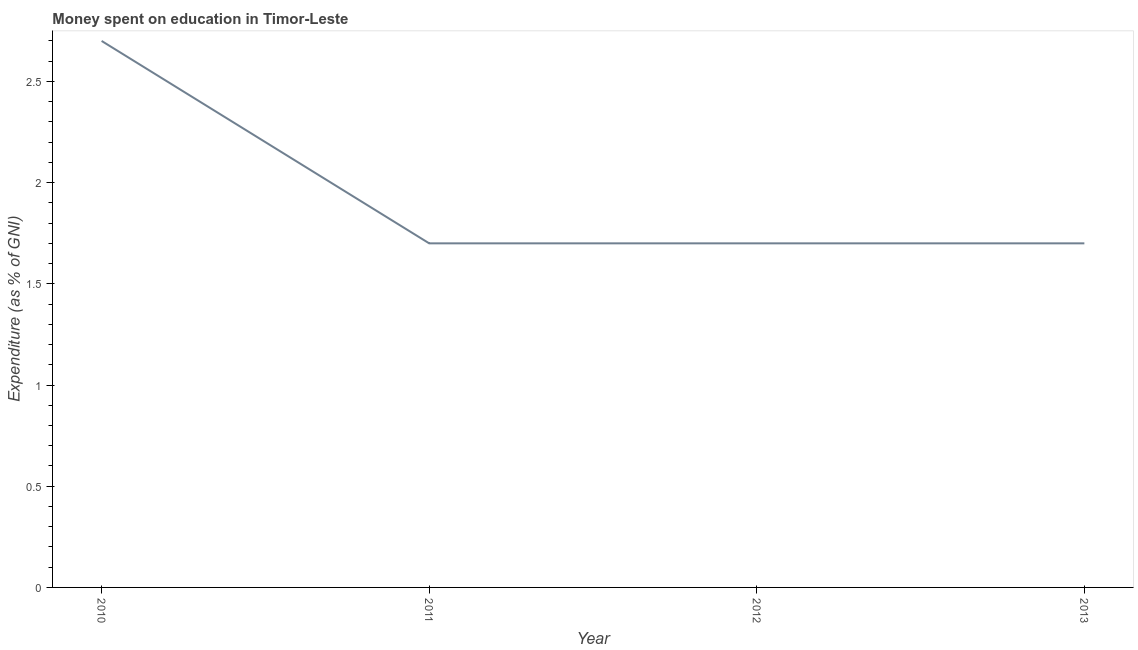Across all years, what is the maximum expenditure on education?
Your response must be concise. 2.7. In which year was the expenditure on education minimum?
Give a very brief answer. 2011. What is the sum of the expenditure on education?
Your response must be concise. 7.8. What is the difference between the expenditure on education in 2010 and 2012?
Keep it short and to the point. 1. What is the average expenditure on education per year?
Offer a terse response. 1.95. What is the median expenditure on education?
Offer a terse response. 1.7. In how many years, is the expenditure on education greater than 1.6 %?
Keep it short and to the point. 4. Do a majority of the years between 2013 and 2012 (inclusive) have expenditure on education greater than 1 %?
Offer a very short reply. No. What is the ratio of the expenditure on education in 2011 to that in 2013?
Your answer should be compact. 1. Is the expenditure on education in 2010 less than that in 2012?
Ensure brevity in your answer.  No. What is the difference between the highest and the second highest expenditure on education?
Give a very brief answer. 1. Is the sum of the expenditure on education in 2011 and 2013 greater than the maximum expenditure on education across all years?
Provide a short and direct response. Yes. What is the difference between the highest and the lowest expenditure on education?
Make the answer very short. 1. How many years are there in the graph?
Provide a succinct answer. 4. Does the graph contain any zero values?
Your answer should be very brief. No. What is the title of the graph?
Make the answer very short. Money spent on education in Timor-Leste. What is the label or title of the Y-axis?
Provide a succinct answer. Expenditure (as % of GNI). What is the Expenditure (as % of GNI) of 2010?
Ensure brevity in your answer.  2.7. What is the Expenditure (as % of GNI) of 2011?
Your response must be concise. 1.7. What is the Expenditure (as % of GNI) in 2012?
Ensure brevity in your answer.  1.7. What is the difference between the Expenditure (as % of GNI) in 2010 and 2012?
Make the answer very short. 1. What is the difference between the Expenditure (as % of GNI) in 2010 and 2013?
Offer a terse response. 1. What is the ratio of the Expenditure (as % of GNI) in 2010 to that in 2011?
Keep it short and to the point. 1.59. What is the ratio of the Expenditure (as % of GNI) in 2010 to that in 2012?
Ensure brevity in your answer.  1.59. What is the ratio of the Expenditure (as % of GNI) in 2010 to that in 2013?
Give a very brief answer. 1.59. What is the ratio of the Expenditure (as % of GNI) in 2012 to that in 2013?
Your answer should be very brief. 1. 